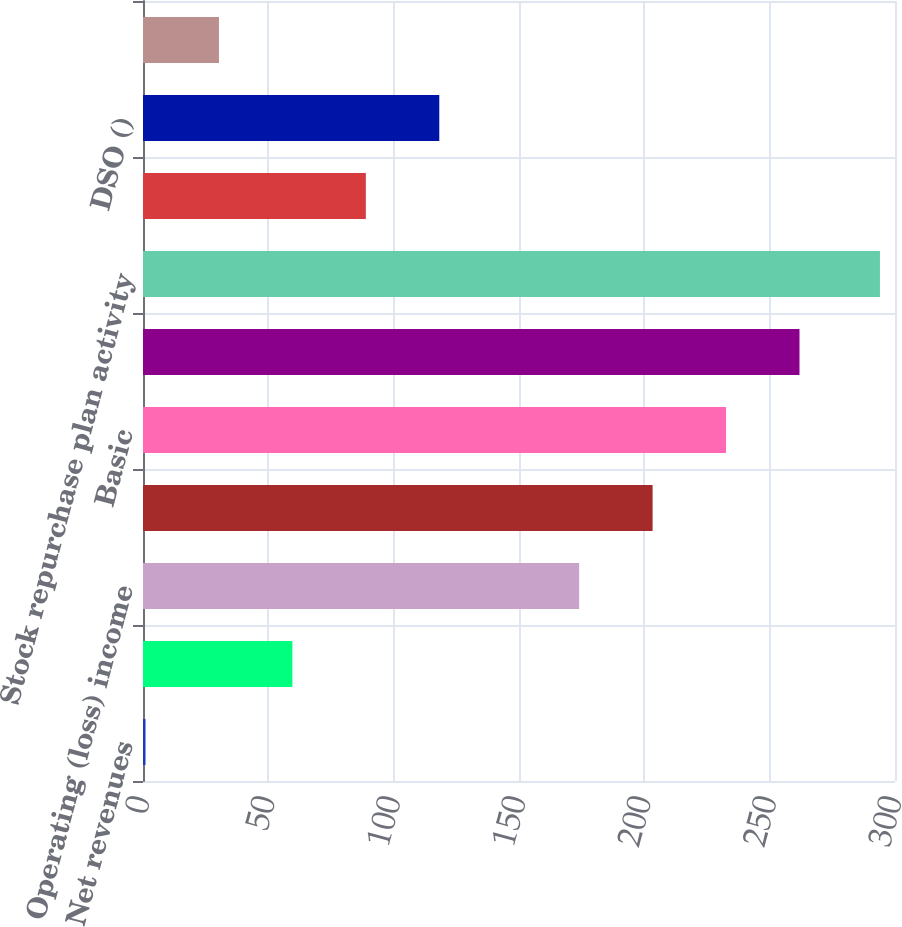Convert chart to OTSL. <chart><loc_0><loc_0><loc_500><loc_500><bar_chart><fcel>Net revenues<fcel>Gross Margin<fcel>Operating (loss) income<fcel>Net (loss) income<fcel>Basic<fcel>Diluted<fcel>Stock repurchase plan activity<fcel>Operating cash flows<fcel>DSO ()<fcel>Deferred revenue<nl><fcel>1<fcel>59.6<fcel>174<fcel>203.3<fcel>232.6<fcel>261.9<fcel>294<fcel>88.9<fcel>118.2<fcel>30.3<nl></chart> 